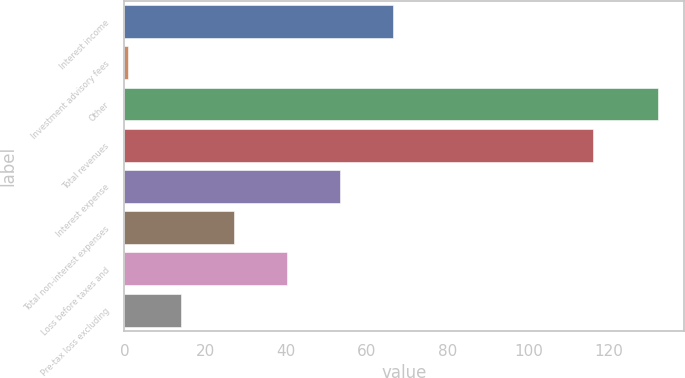Convert chart. <chart><loc_0><loc_0><loc_500><loc_500><bar_chart><fcel>Interest income<fcel>Investment advisory fees<fcel>Other<fcel>Total revenues<fcel>Interest expense<fcel>Total non-interest expenses<fcel>Loss before taxes and<fcel>Pre-tax loss excluding<nl><fcel>66.5<fcel>1<fcel>132<fcel>116<fcel>53.4<fcel>27.2<fcel>40.3<fcel>14.1<nl></chart> 